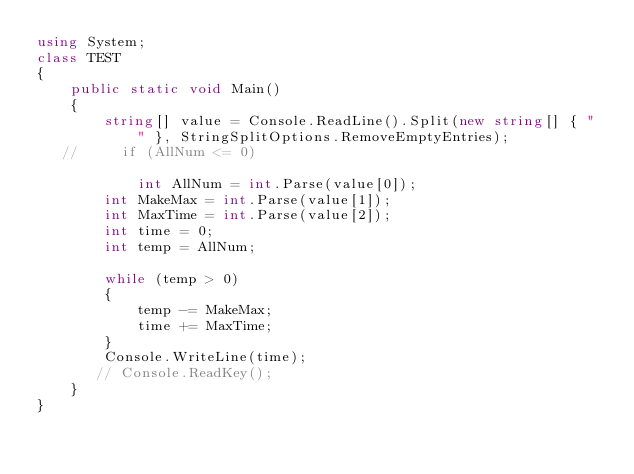<code> <loc_0><loc_0><loc_500><loc_500><_C#_>using System;
class TEST
{
    public static void Main()
    {
        string[] value = Console.ReadLine().Split(new string[] { " " }, StringSplitOptions.RemoveEmptyEntries);
   //     if (AllNum <= 0)

            int AllNum = int.Parse(value[0]);
        int MakeMax = int.Parse(value[1]);
        int MaxTime = int.Parse(value[2]);
        int time = 0;
        int temp = AllNum;

        while (temp > 0)
        {
            temp -= MakeMax;
            time += MaxTime;
        }
        Console.WriteLine(time);
       // Console.ReadKey();
    }
}</code> 